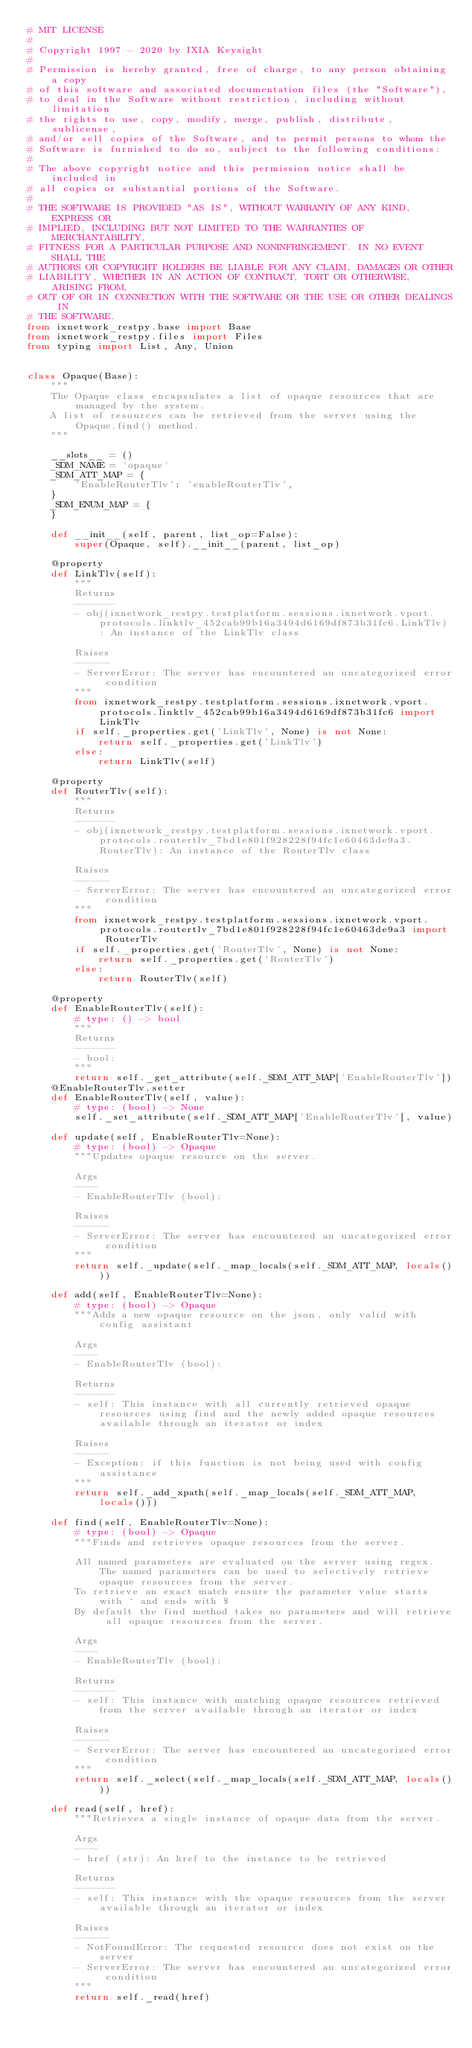<code> <loc_0><loc_0><loc_500><loc_500><_Python_># MIT LICENSE
#
# Copyright 1997 - 2020 by IXIA Keysight
#
# Permission is hereby granted, free of charge, to any person obtaining a copy
# of this software and associated documentation files (the "Software"),
# to deal in the Software without restriction, including without limitation
# the rights to use, copy, modify, merge, publish, distribute, sublicense,
# and/or sell copies of the Software, and to permit persons to whom the
# Software is furnished to do so, subject to the following conditions:
#
# The above copyright notice and this permission notice shall be included in
# all copies or substantial portions of the Software.
#
# THE SOFTWARE IS PROVIDED "AS IS", WITHOUT WARRANTY OF ANY KIND, EXPRESS OR
# IMPLIED, INCLUDING BUT NOT LIMITED TO THE WARRANTIES OF MERCHANTABILITY,
# FITNESS FOR A PARTICULAR PURPOSE AND NONINFRINGEMENT. IN NO EVENT SHALL THE
# AUTHORS OR COPYRIGHT HOLDERS BE LIABLE FOR ANY CLAIM, DAMAGES OR OTHER
# LIABILITY, WHETHER IN AN ACTION OF CONTRACT, TORT OR OTHERWISE, ARISING FROM,
# OUT OF OR IN CONNECTION WITH THE SOFTWARE OR THE USE OR OTHER DEALINGS IN
# THE SOFTWARE. 
from ixnetwork_restpy.base import Base
from ixnetwork_restpy.files import Files
from typing import List, Any, Union


class Opaque(Base):
    """
    The Opaque class encapsulates a list of opaque resources that are managed by the system.
    A list of resources can be retrieved from the server using the Opaque.find() method.
    """

    __slots__ = ()
    _SDM_NAME = 'opaque'
    _SDM_ATT_MAP = {
        'EnableRouterTlv': 'enableRouterTlv',
    }
    _SDM_ENUM_MAP = {
    }

    def __init__(self, parent, list_op=False):
        super(Opaque, self).__init__(parent, list_op)

    @property
    def LinkTlv(self):
        """
        Returns
        -------
        - obj(ixnetwork_restpy.testplatform.sessions.ixnetwork.vport.protocols.linktlv_452cab99b16a3494d6169df873b31fc6.LinkTlv): An instance of the LinkTlv class

        Raises
        ------
        - ServerError: The server has encountered an uncategorized error condition
        """
        from ixnetwork_restpy.testplatform.sessions.ixnetwork.vport.protocols.linktlv_452cab99b16a3494d6169df873b31fc6 import LinkTlv
        if self._properties.get('LinkTlv', None) is not None:
            return self._properties.get('LinkTlv')
        else:
            return LinkTlv(self)

    @property
    def RouterTlv(self):
        """
        Returns
        -------
        - obj(ixnetwork_restpy.testplatform.sessions.ixnetwork.vport.protocols.routertlv_7bd1e801f928228f94fc1e60463de9a3.RouterTlv): An instance of the RouterTlv class

        Raises
        ------
        - ServerError: The server has encountered an uncategorized error condition
        """
        from ixnetwork_restpy.testplatform.sessions.ixnetwork.vport.protocols.routertlv_7bd1e801f928228f94fc1e60463de9a3 import RouterTlv
        if self._properties.get('RouterTlv', None) is not None:
            return self._properties.get('RouterTlv')
        else:
            return RouterTlv(self)

    @property
    def EnableRouterTlv(self):
        # type: () -> bool
        """
        Returns
        -------
        - bool: 
        """
        return self._get_attribute(self._SDM_ATT_MAP['EnableRouterTlv'])
    @EnableRouterTlv.setter
    def EnableRouterTlv(self, value):
        # type: (bool) -> None
        self._set_attribute(self._SDM_ATT_MAP['EnableRouterTlv'], value)

    def update(self, EnableRouterTlv=None):
        # type: (bool) -> Opaque
        """Updates opaque resource on the server.

        Args
        ----
        - EnableRouterTlv (bool): 

        Raises
        ------
        - ServerError: The server has encountered an uncategorized error condition
        """
        return self._update(self._map_locals(self._SDM_ATT_MAP, locals()))

    def add(self, EnableRouterTlv=None):
        # type: (bool) -> Opaque
        """Adds a new opaque resource on the json, only valid with config assistant

        Args
        ----
        - EnableRouterTlv (bool): 

        Returns
        -------
        - self: This instance with all currently retrieved opaque resources using find and the newly added opaque resources available through an iterator or index

        Raises
        ------
        - Exception: if this function is not being used with config assistance
        """
        return self._add_xpath(self._map_locals(self._SDM_ATT_MAP, locals()))

    def find(self, EnableRouterTlv=None):
        # type: (bool) -> Opaque
        """Finds and retrieves opaque resources from the server.

        All named parameters are evaluated on the server using regex. The named parameters can be used to selectively retrieve opaque resources from the server.
        To retrieve an exact match ensure the parameter value starts with ^ and ends with $
        By default the find method takes no parameters and will retrieve all opaque resources from the server.

        Args
        ----
        - EnableRouterTlv (bool): 

        Returns
        -------
        - self: This instance with matching opaque resources retrieved from the server available through an iterator or index

        Raises
        ------
        - ServerError: The server has encountered an uncategorized error condition
        """
        return self._select(self._map_locals(self._SDM_ATT_MAP, locals()))

    def read(self, href):
        """Retrieves a single instance of opaque data from the server.

        Args
        ----
        - href (str): An href to the instance to be retrieved

        Returns
        -------
        - self: This instance with the opaque resources from the server available through an iterator or index

        Raises
        ------
        - NotFoundError: The requested resource does not exist on the server
        - ServerError: The server has encountered an uncategorized error condition
        """
        return self._read(href)
</code> 